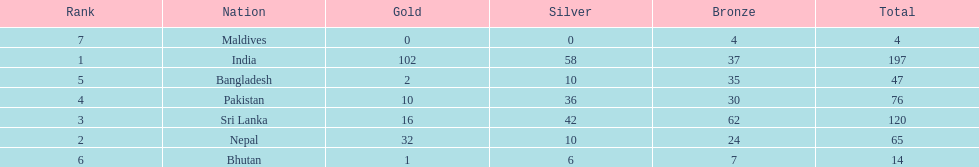How many countries have one more than 10 gold medals? 3. 